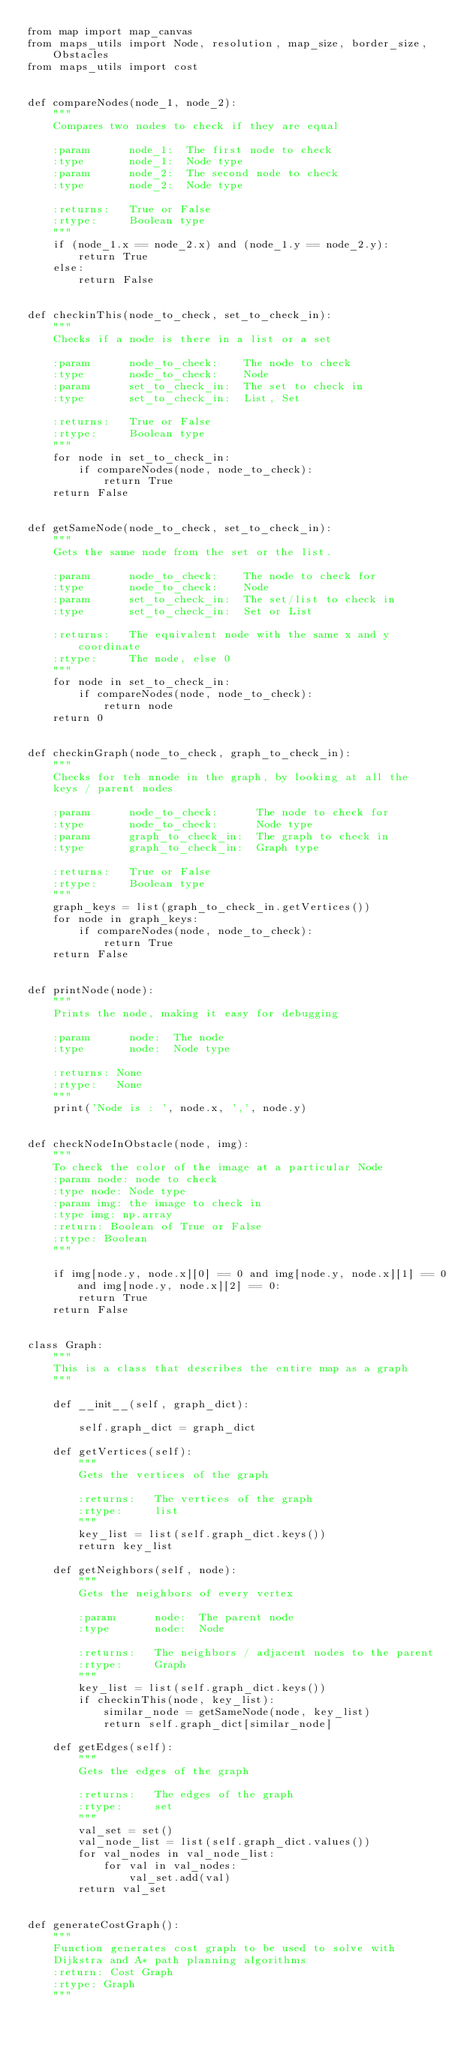Convert code to text. <code><loc_0><loc_0><loc_500><loc_500><_Python_>from map import map_canvas
from maps_utils import Node, resolution, map_size, border_size, Obstacles
from maps_utils import cost


def compareNodes(node_1, node_2):
    """
    Compares two nodes to check if they are equal
    
    :param      node_1:  The first node to check
    :type       node_1:  Node type
    :param      node_2:  The second node to check
    :type       node_2:  Node type
    
    :returns:   True or False
    :rtype:     Boolean type
    """
    if (node_1.x == node_2.x) and (node_1.y == node_2.y):
        return True
    else:
        return False


def checkinThis(node_to_check, set_to_check_in):
    """
    Checks if a node is there in a list or a set
    
    :param      node_to_check:    The node to check
    :type       node_to_check:    Node
    :param      set_to_check_in:  The set to check in
    :type       set_to_check_in:  List, Set
    
    :returns:   True or False
    :rtype:     Boolean type
    """
    for node in set_to_check_in:
        if compareNodes(node, node_to_check):
            return True
    return False


def getSameNode(node_to_check, set_to_check_in):
    """
    Gets the same node from the set or the list.
    
    :param      node_to_check:    The node to check for
    :type       node_to_check:    Node
    :param      set_to_check_in:  The set/list to check in
    :type       set_to_check_in:  Set or List
    
    :returns:   The equivalent node with the same x and y coordinate
    :rtype:     The node, else 0
    """
    for node in set_to_check_in:
        if compareNodes(node, node_to_check):
            return node
    return 0


def checkinGraph(node_to_check, graph_to_check_in):
    """
    Checks for teh nnode in the graph, by looking at all the 
    keys / parent nodes
    
    :param      node_to_check:      The node to check for
    :type       node_to_check:      Node type
    :param      graph_to_check_in:  The graph to check in
    :type       graph_to_check_in:  Graph type
    
    :returns:   True or False
    :rtype:     Boolean type
    """
    graph_keys = list(graph_to_check_in.getVertices())
    for node in graph_keys:
        if compareNodes(node, node_to_check):
            return True
    return False


def printNode(node):
    """
    Prints the node, making it easy for debugging
    
    :param      node:  The node
    :type       node:  Node type
    
    :returns: None
    :rtype:   None
    """
    print('Node is : ', node.x, ',', node.y)


def checkNodeInObstacle(node, img):
    """
    To check the color of the image at a particular Node
    :param node: node to check
    :type node: Node type
    :param img: the image to check in
    :type img: np.array
    :return: Boolean of True or False
    :rtype: Boolean
    """

    if img[node.y, node.x][0] == 0 and img[node.y, node.x][1] == 0 and img[node.y, node.x][2] == 0:
        return True
    return False


class Graph:
    """
    This is a class that describes the entire map as a graph
    """

    def __init__(self, graph_dict):

        self.graph_dict = graph_dict

    def getVertices(self):
        """
        Gets the vertices of the graph
        
        :returns:   The vertices of the graph
        :rtype:     list
        """
        key_list = list(self.graph_dict.keys())
        return key_list

    def getNeighbors(self, node):
        """
        Gets the neighbors of every vertex
        
        :param      node:  The parent node
        :type       node:  Node
        
        :returns:   The neighbors / adjacent nodes to the parent
        :rtype:     Graph
        """
        key_list = list(self.graph_dict.keys())
        if checkinThis(node, key_list):
            similar_node = getSameNode(node, key_list)
            return self.graph_dict[similar_node]

    def getEdges(self):
        """
        Gets the edges of the graph
        
        :returns:   The edges of the graph
        :rtype:     set
        """
        val_set = set()
        val_node_list = list(self.graph_dict.values())
        for val_nodes in val_node_list:
            for val in val_nodes:
                val_set.add(val)
        return val_set


def generateCostGraph():
    """
    Function generates cost graph to be used to solve with
    Dijkstra and A* path planning algorithms
    :return: Cost Graph
    :rtype: Graph
    """</code> 